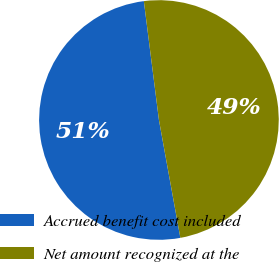Convert chart to OTSL. <chart><loc_0><loc_0><loc_500><loc_500><pie_chart><fcel>Accrued benefit cost included<fcel>Net amount recognized at the<nl><fcel>50.85%<fcel>49.15%<nl></chart> 